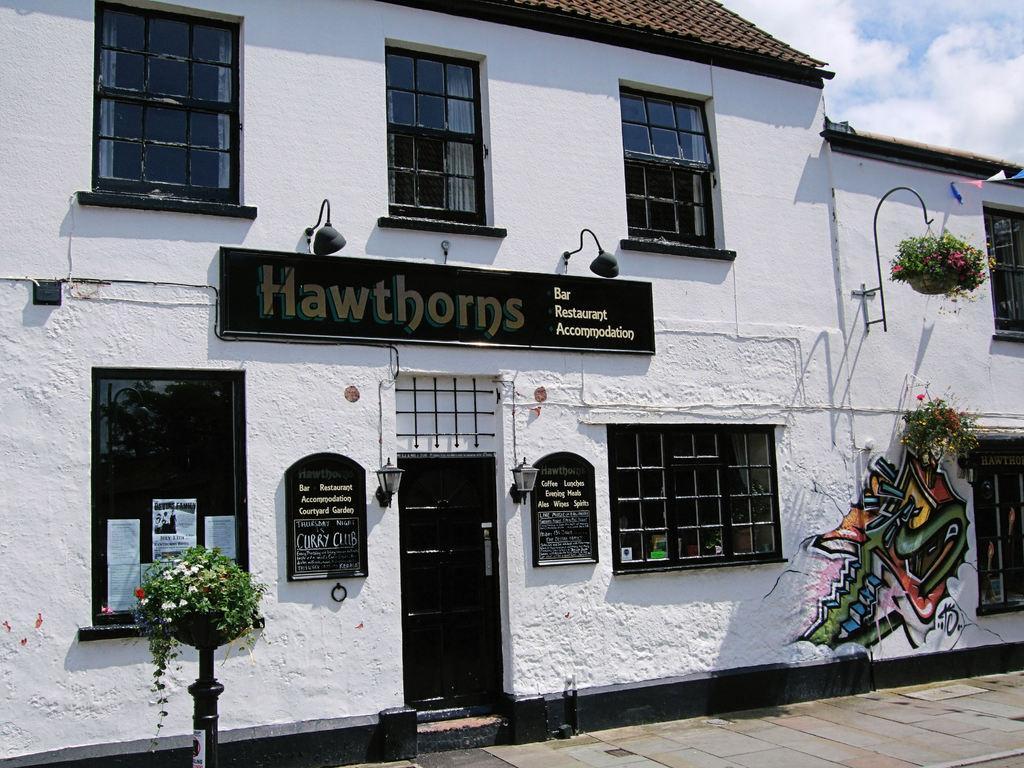Could you give a brief overview of what you see in this image? In this picture I can see the hoarding. I can see the plants. I can see glass windows. I can see the door. I can see clouds in the sky. 